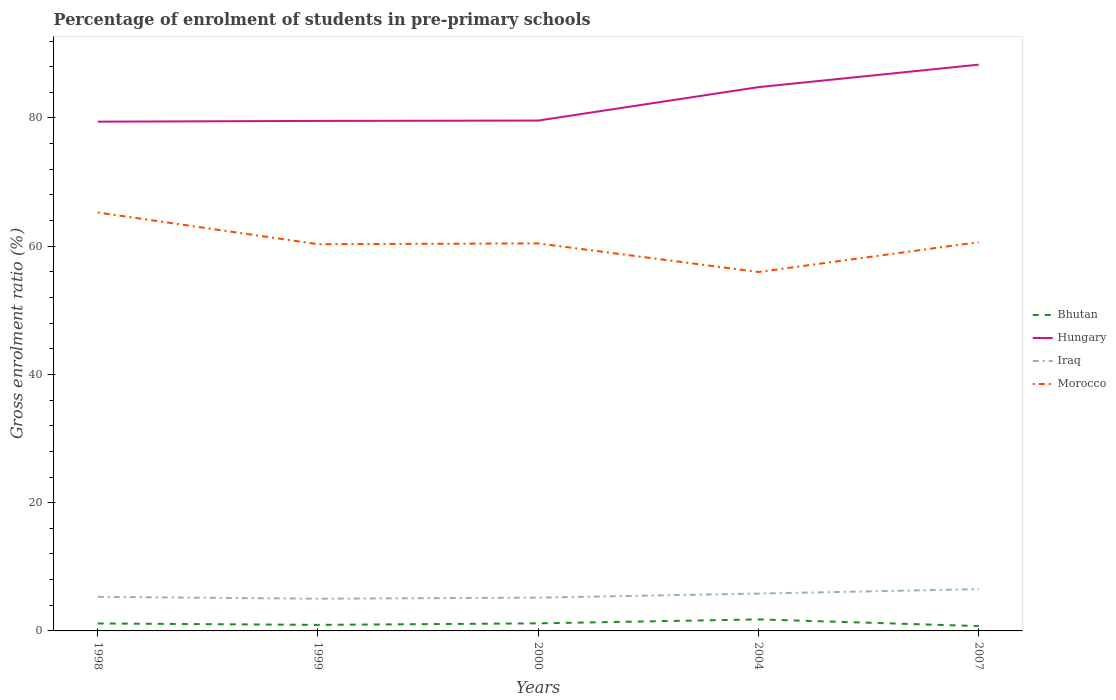Across all years, what is the maximum percentage of students enrolled in pre-primary schools in Morocco?
Give a very brief answer. 55.98. What is the total percentage of students enrolled in pre-primary schools in Iraq in the graph?
Offer a terse response. -0.5. What is the difference between the highest and the second highest percentage of students enrolled in pre-primary schools in Bhutan?
Your answer should be compact. 1.04. What is the difference between the highest and the lowest percentage of students enrolled in pre-primary schools in Morocco?
Give a very brief answer. 2. Is the percentage of students enrolled in pre-primary schools in Bhutan strictly greater than the percentage of students enrolled in pre-primary schools in Morocco over the years?
Give a very brief answer. Yes. Are the values on the major ticks of Y-axis written in scientific E-notation?
Keep it short and to the point. No. Does the graph contain any zero values?
Your answer should be very brief. No. Does the graph contain grids?
Make the answer very short. No. How many legend labels are there?
Make the answer very short. 4. How are the legend labels stacked?
Your answer should be very brief. Vertical. What is the title of the graph?
Provide a succinct answer. Percentage of enrolment of students in pre-primary schools. Does "American Samoa" appear as one of the legend labels in the graph?
Your response must be concise. No. What is the label or title of the X-axis?
Provide a succinct answer. Years. What is the label or title of the Y-axis?
Keep it short and to the point. Gross enrolment ratio (%). What is the Gross enrolment ratio (%) in Bhutan in 1998?
Your answer should be compact. 1.16. What is the Gross enrolment ratio (%) in Hungary in 1998?
Your answer should be very brief. 79.42. What is the Gross enrolment ratio (%) in Iraq in 1998?
Ensure brevity in your answer.  5.32. What is the Gross enrolment ratio (%) of Morocco in 1998?
Provide a short and direct response. 65.26. What is the Gross enrolment ratio (%) of Bhutan in 1999?
Keep it short and to the point. 0.94. What is the Gross enrolment ratio (%) in Hungary in 1999?
Ensure brevity in your answer.  79.54. What is the Gross enrolment ratio (%) in Iraq in 1999?
Ensure brevity in your answer.  5.02. What is the Gross enrolment ratio (%) in Morocco in 1999?
Keep it short and to the point. 60.31. What is the Gross enrolment ratio (%) in Bhutan in 2000?
Your answer should be very brief. 1.18. What is the Gross enrolment ratio (%) of Hungary in 2000?
Offer a very short reply. 79.6. What is the Gross enrolment ratio (%) in Iraq in 2000?
Provide a succinct answer. 5.19. What is the Gross enrolment ratio (%) in Morocco in 2000?
Your response must be concise. 60.43. What is the Gross enrolment ratio (%) in Bhutan in 2004?
Make the answer very short. 1.8. What is the Gross enrolment ratio (%) in Hungary in 2004?
Your response must be concise. 84.81. What is the Gross enrolment ratio (%) of Iraq in 2004?
Ensure brevity in your answer.  5.82. What is the Gross enrolment ratio (%) in Morocco in 2004?
Offer a very short reply. 55.98. What is the Gross enrolment ratio (%) in Bhutan in 2007?
Keep it short and to the point. 0.76. What is the Gross enrolment ratio (%) of Hungary in 2007?
Ensure brevity in your answer.  88.32. What is the Gross enrolment ratio (%) in Iraq in 2007?
Offer a very short reply. 6.52. What is the Gross enrolment ratio (%) of Morocco in 2007?
Offer a terse response. 60.63. Across all years, what is the maximum Gross enrolment ratio (%) in Bhutan?
Provide a succinct answer. 1.8. Across all years, what is the maximum Gross enrolment ratio (%) of Hungary?
Provide a succinct answer. 88.32. Across all years, what is the maximum Gross enrolment ratio (%) of Iraq?
Ensure brevity in your answer.  6.52. Across all years, what is the maximum Gross enrolment ratio (%) of Morocco?
Provide a succinct answer. 65.26. Across all years, what is the minimum Gross enrolment ratio (%) in Bhutan?
Keep it short and to the point. 0.76. Across all years, what is the minimum Gross enrolment ratio (%) of Hungary?
Give a very brief answer. 79.42. Across all years, what is the minimum Gross enrolment ratio (%) of Iraq?
Provide a succinct answer. 5.02. Across all years, what is the minimum Gross enrolment ratio (%) in Morocco?
Your response must be concise. 55.98. What is the total Gross enrolment ratio (%) of Bhutan in the graph?
Give a very brief answer. 5.84. What is the total Gross enrolment ratio (%) in Hungary in the graph?
Offer a very short reply. 411.69. What is the total Gross enrolment ratio (%) of Iraq in the graph?
Keep it short and to the point. 27.87. What is the total Gross enrolment ratio (%) in Morocco in the graph?
Keep it short and to the point. 302.61. What is the difference between the Gross enrolment ratio (%) in Bhutan in 1998 and that in 1999?
Provide a short and direct response. 0.22. What is the difference between the Gross enrolment ratio (%) in Hungary in 1998 and that in 1999?
Give a very brief answer. -0.12. What is the difference between the Gross enrolment ratio (%) of Iraq in 1998 and that in 1999?
Give a very brief answer. 0.29. What is the difference between the Gross enrolment ratio (%) in Morocco in 1998 and that in 1999?
Provide a succinct answer. 4.94. What is the difference between the Gross enrolment ratio (%) of Bhutan in 1998 and that in 2000?
Give a very brief answer. -0.02. What is the difference between the Gross enrolment ratio (%) in Hungary in 1998 and that in 2000?
Give a very brief answer. -0.17. What is the difference between the Gross enrolment ratio (%) of Iraq in 1998 and that in 2000?
Keep it short and to the point. 0.12. What is the difference between the Gross enrolment ratio (%) in Morocco in 1998 and that in 2000?
Your answer should be compact. 4.82. What is the difference between the Gross enrolment ratio (%) of Bhutan in 1998 and that in 2004?
Make the answer very short. -0.63. What is the difference between the Gross enrolment ratio (%) in Hungary in 1998 and that in 2004?
Offer a terse response. -5.39. What is the difference between the Gross enrolment ratio (%) of Iraq in 1998 and that in 2004?
Give a very brief answer. -0.5. What is the difference between the Gross enrolment ratio (%) of Morocco in 1998 and that in 2004?
Offer a very short reply. 9.28. What is the difference between the Gross enrolment ratio (%) of Bhutan in 1998 and that in 2007?
Your answer should be very brief. 0.41. What is the difference between the Gross enrolment ratio (%) of Hungary in 1998 and that in 2007?
Offer a terse response. -8.89. What is the difference between the Gross enrolment ratio (%) of Iraq in 1998 and that in 2007?
Make the answer very short. -1.2. What is the difference between the Gross enrolment ratio (%) in Morocco in 1998 and that in 2007?
Ensure brevity in your answer.  4.63. What is the difference between the Gross enrolment ratio (%) in Bhutan in 1999 and that in 2000?
Make the answer very short. -0.24. What is the difference between the Gross enrolment ratio (%) in Hungary in 1999 and that in 2000?
Your response must be concise. -0.05. What is the difference between the Gross enrolment ratio (%) in Iraq in 1999 and that in 2000?
Provide a short and direct response. -0.17. What is the difference between the Gross enrolment ratio (%) in Morocco in 1999 and that in 2000?
Provide a succinct answer. -0.12. What is the difference between the Gross enrolment ratio (%) in Bhutan in 1999 and that in 2004?
Your answer should be compact. -0.85. What is the difference between the Gross enrolment ratio (%) of Hungary in 1999 and that in 2004?
Your answer should be very brief. -5.27. What is the difference between the Gross enrolment ratio (%) of Iraq in 1999 and that in 2004?
Ensure brevity in your answer.  -0.8. What is the difference between the Gross enrolment ratio (%) of Morocco in 1999 and that in 2004?
Offer a terse response. 4.34. What is the difference between the Gross enrolment ratio (%) of Bhutan in 1999 and that in 2007?
Your answer should be very brief. 0.19. What is the difference between the Gross enrolment ratio (%) in Hungary in 1999 and that in 2007?
Provide a succinct answer. -8.77. What is the difference between the Gross enrolment ratio (%) in Iraq in 1999 and that in 2007?
Your answer should be compact. -1.49. What is the difference between the Gross enrolment ratio (%) in Morocco in 1999 and that in 2007?
Make the answer very short. -0.31. What is the difference between the Gross enrolment ratio (%) of Bhutan in 2000 and that in 2004?
Ensure brevity in your answer.  -0.62. What is the difference between the Gross enrolment ratio (%) of Hungary in 2000 and that in 2004?
Provide a short and direct response. -5.21. What is the difference between the Gross enrolment ratio (%) in Iraq in 2000 and that in 2004?
Your answer should be very brief. -0.63. What is the difference between the Gross enrolment ratio (%) in Morocco in 2000 and that in 2004?
Your answer should be compact. 4.45. What is the difference between the Gross enrolment ratio (%) in Bhutan in 2000 and that in 2007?
Offer a very short reply. 0.43. What is the difference between the Gross enrolment ratio (%) of Hungary in 2000 and that in 2007?
Offer a very short reply. -8.72. What is the difference between the Gross enrolment ratio (%) in Iraq in 2000 and that in 2007?
Offer a terse response. -1.32. What is the difference between the Gross enrolment ratio (%) in Morocco in 2000 and that in 2007?
Your answer should be compact. -0.19. What is the difference between the Gross enrolment ratio (%) in Bhutan in 2004 and that in 2007?
Keep it short and to the point. 1.04. What is the difference between the Gross enrolment ratio (%) of Hungary in 2004 and that in 2007?
Ensure brevity in your answer.  -3.51. What is the difference between the Gross enrolment ratio (%) of Iraq in 2004 and that in 2007?
Ensure brevity in your answer.  -0.69. What is the difference between the Gross enrolment ratio (%) of Morocco in 2004 and that in 2007?
Make the answer very short. -4.65. What is the difference between the Gross enrolment ratio (%) in Bhutan in 1998 and the Gross enrolment ratio (%) in Hungary in 1999?
Offer a very short reply. -78.38. What is the difference between the Gross enrolment ratio (%) in Bhutan in 1998 and the Gross enrolment ratio (%) in Iraq in 1999?
Your answer should be compact. -3.86. What is the difference between the Gross enrolment ratio (%) of Bhutan in 1998 and the Gross enrolment ratio (%) of Morocco in 1999?
Your answer should be compact. -59.15. What is the difference between the Gross enrolment ratio (%) in Hungary in 1998 and the Gross enrolment ratio (%) in Iraq in 1999?
Offer a terse response. 74.4. What is the difference between the Gross enrolment ratio (%) of Hungary in 1998 and the Gross enrolment ratio (%) of Morocco in 1999?
Make the answer very short. 19.11. What is the difference between the Gross enrolment ratio (%) of Iraq in 1998 and the Gross enrolment ratio (%) of Morocco in 1999?
Offer a very short reply. -55. What is the difference between the Gross enrolment ratio (%) in Bhutan in 1998 and the Gross enrolment ratio (%) in Hungary in 2000?
Your answer should be compact. -78.43. What is the difference between the Gross enrolment ratio (%) of Bhutan in 1998 and the Gross enrolment ratio (%) of Iraq in 2000?
Give a very brief answer. -4.03. What is the difference between the Gross enrolment ratio (%) in Bhutan in 1998 and the Gross enrolment ratio (%) in Morocco in 2000?
Your answer should be very brief. -59.27. What is the difference between the Gross enrolment ratio (%) in Hungary in 1998 and the Gross enrolment ratio (%) in Iraq in 2000?
Provide a short and direct response. 74.23. What is the difference between the Gross enrolment ratio (%) in Hungary in 1998 and the Gross enrolment ratio (%) in Morocco in 2000?
Your answer should be compact. 18.99. What is the difference between the Gross enrolment ratio (%) of Iraq in 1998 and the Gross enrolment ratio (%) of Morocco in 2000?
Give a very brief answer. -55.12. What is the difference between the Gross enrolment ratio (%) of Bhutan in 1998 and the Gross enrolment ratio (%) of Hungary in 2004?
Your answer should be compact. -83.65. What is the difference between the Gross enrolment ratio (%) of Bhutan in 1998 and the Gross enrolment ratio (%) of Iraq in 2004?
Offer a very short reply. -4.66. What is the difference between the Gross enrolment ratio (%) of Bhutan in 1998 and the Gross enrolment ratio (%) of Morocco in 2004?
Ensure brevity in your answer.  -54.82. What is the difference between the Gross enrolment ratio (%) of Hungary in 1998 and the Gross enrolment ratio (%) of Iraq in 2004?
Provide a succinct answer. 73.6. What is the difference between the Gross enrolment ratio (%) in Hungary in 1998 and the Gross enrolment ratio (%) in Morocco in 2004?
Your answer should be compact. 23.44. What is the difference between the Gross enrolment ratio (%) of Iraq in 1998 and the Gross enrolment ratio (%) of Morocco in 2004?
Offer a terse response. -50.66. What is the difference between the Gross enrolment ratio (%) of Bhutan in 1998 and the Gross enrolment ratio (%) of Hungary in 2007?
Give a very brief answer. -87.15. What is the difference between the Gross enrolment ratio (%) in Bhutan in 1998 and the Gross enrolment ratio (%) in Iraq in 2007?
Your answer should be very brief. -5.35. What is the difference between the Gross enrolment ratio (%) of Bhutan in 1998 and the Gross enrolment ratio (%) of Morocco in 2007?
Offer a very short reply. -59.46. What is the difference between the Gross enrolment ratio (%) in Hungary in 1998 and the Gross enrolment ratio (%) in Iraq in 2007?
Your answer should be compact. 72.91. What is the difference between the Gross enrolment ratio (%) in Hungary in 1998 and the Gross enrolment ratio (%) in Morocco in 2007?
Provide a short and direct response. 18.8. What is the difference between the Gross enrolment ratio (%) in Iraq in 1998 and the Gross enrolment ratio (%) in Morocco in 2007?
Your answer should be very brief. -55.31. What is the difference between the Gross enrolment ratio (%) of Bhutan in 1999 and the Gross enrolment ratio (%) of Hungary in 2000?
Ensure brevity in your answer.  -78.65. What is the difference between the Gross enrolment ratio (%) in Bhutan in 1999 and the Gross enrolment ratio (%) in Iraq in 2000?
Provide a succinct answer. -4.25. What is the difference between the Gross enrolment ratio (%) in Bhutan in 1999 and the Gross enrolment ratio (%) in Morocco in 2000?
Your answer should be compact. -59.49. What is the difference between the Gross enrolment ratio (%) of Hungary in 1999 and the Gross enrolment ratio (%) of Iraq in 2000?
Give a very brief answer. 74.35. What is the difference between the Gross enrolment ratio (%) of Hungary in 1999 and the Gross enrolment ratio (%) of Morocco in 2000?
Ensure brevity in your answer.  19.11. What is the difference between the Gross enrolment ratio (%) of Iraq in 1999 and the Gross enrolment ratio (%) of Morocco in 2000?
Your answer should be compact. -55.41. What is the difference between the Gross enrolment ratio (%) of Bhutan in 1999 and the Gross enrolment ratio (%) of Hungary in 2004?
Offer a terse response. -83.87. What is the difference between the Gross enrolment ratio (%) in Bhutan in 1999 and the Gross enrolment ratio (%) in Iraq in 2004?
Offer a very short reply. -4.88. What is the difference between the Gross enrolment ratio (%) in Bhutan in 1999 and the Gross enrolment ratio (%) in Morocco in 2004?
Keep it short and to the point. -55.04. What is the difference between the Gross enrolment ratio (%) of Hungary in 1999 and the Gross enrolment ratio (%) of Iraq in 2004?
Provide a short and direct response. 73.72. What is the difference between the Gross enrolment ratio (%) in Hungary in 1999 and the Gross enrolment ratio (%) in Morocco in 2004?
Offer a terse response. 23.56. What is the difference between the Gross enrolment ratio (%) in Iraq in 1999 and the Gross enrolment ratio (%) in Morocco in 2004?
Make the answer very short. -50.96. What is the difference between the Gross enrolment ratio (%) in Bhutan in 1999 and the Gross enrolment ratio (%) in Hungary in 2007?
Provide a short and direct response. -87.37. What is the difference between the Gross enrolment ratio (%) in Bhutan in 1999 and the Gross enrolment ratio (%) in Iraq in 2007?
Ensure brevity in your answer.  -5.57. What is the difference between the Gross enrolment ratio (%) of Bhutan in 1999 and the Gross enrolment ratio (%) of Morocco in 2007?
Ensure brevity in your answer.  -59.68. What is the difference between the Gross enrolment ratio (%) of Hungary in 1999 and the Gross enrolment ratio (%) of Iraq in 2007?
Offer a terse response. 73.03. What is the difference between the Gross enrolment ratio (%) in Hungary in 1999 and the Gross enrolment ratio (%) in Morocco in 2007?
Your answer should be compact. 18.92. What is the difference between the Gross enrolment ratio (%) in Iraq in 1999 and the Gross enrolment ratio (%) in Morocco in 2007?
Your answer should be very brief. -55.6. What is the difference between the Gross enrolment ratio (%) in Bhutan in 2000 and the Gross enrolment ratio (%) in Hungary in 2004?
Ensure brevity in your answer.  -83.63. What is the difference between the Gross enrolment ratio (%) of Bhutan in 2000 and the Gross enrolment ratio (%) of Iraq in 2004?
Your answer should be very brief. -4.64. What is the difference between the Gross enrolment ratio (%) in Bhutan in 2000 and the Gross enrolment ratio (%) in Morocco in 2004?
Your answer should be compact. -54.8. What is the difference between the Gross enrolment ratio (%) of Hungary in 2000 and the Gross enrolment ratio (%) of Iraq in 2004?
Provide a succinct answer. 73.77. What is the difference between the Gross enrolment ratio (%) of Hungary in 2000 and the Gross enrolment ratio (%) of Morocco in 2004?
Give a very brief answer. 23.62. What is the difference between the Gross enrolment ratio (%) of Iraq in 2000 and the Gross enrolment ratio (%) of Morocco in 2004?
Provide a short and direct response. -50.79. What is the difference between the Gross enrolment ratio (%) in Bhutan in 2000 and the Gross enrolment ratio (%) in Hungary in 2007?
Your answer should be very brief. -87.13. What is the difference between the Gross enrolment ratio (%) in Bhutan in 2000 and the Gross enrolment ratio (%) in Iraq in 2007?
Make the answer very short. -5.33. What is the difference between the Gross enrolment ratio (%) in Bhutan in 2000 and the Gross enrolment ratio (%) in Morocco in 2007?
Ensure brevity in your answer.  -59.45. What is the difference between the Gross enrolment ratio (%) in Hungary in 2000 and the Gross enrolment ratio (%) in Iraq in 2007?
Your answer should be compact. 73.08. What is the difference between the Gross enrolment ratio (%) of Hungary in 2000 and the Gross enrolment ratio (%) of Morocco in 2007?
Give a very brief answer. 18.97. What is the difference between the Gross enrolment ratio (%) in Iraq in 2000 and the Gross enrolment ratio (%) in Morocco in 2007?
Offer a terse response. -55.43. What is the difference between the Gross enrolment ratio (%) in Bhutan in 2004 and the Gross enrolment ratio (%) in Hungary in 2007?
Your answer should be very brief. -86.52. What is the difference between the Gross enrolment ratio (%) in Bhutan in 2004 and the Gross enrolment ratio (%) in Iraq in 2007?
Your answer should be very brief. -4.72. What is the difference between the Gross enrolment ratio (%) in Bhutan in 2004 and the Gross enrolment ratio (%) in Morocco in 2007?
Keep it short and to the point. -58.83. What is the difference between the Gross enrolment ratio (%) in Hungary in 2004 and the Gross enrolment ratio (%) in Iraq in 2007?
Your response must be concise. 78.29. What is the difference between the Gross enrolment ratio (%) in Hungary in 2004 and the Gross enrolment ratio (%) in Morocco in 2007?
Make the answer very short. 24.18. What is the difference between the Gross enrolment ratio (%) in Iraq in 2004 and the Gross enrolment ratio (%) in Morocco in 2007?
Make the answer very short. -54.8. What is the average Gross enrolment ratio (%) in Bhutan per year?
Provide a short and direct response. 1.17. What is the average Gross enrolment ratio (%) of Hungary per year?
Provide a succinct answer. 82.34. What is the average Gross enrolment ratio (%) of Iraq per year?
Your answer should be very brief. 5.57. What is the average Gross enrolment ratio (%) of Morocco per year?
Your answer should be very brief. 60.52. In the year 1998, what is the difference between the Gross enrolment ratio (%) of Bhutan and Gross enrolment ratio (%) of Hungary?
Make the answer very short. -78.26. In the year 1998, what is the difference between the Gross enrolment ratio (%) of Bhutan and Gross enrolment ratio (%) of Iraq?
Your response must be concise. -4.15. In the year 1998, what is the difference between the Gross enrolment ratio (%) of Bhutan and Gross enrolment ratio (%) of Morocco?
Offer a very short reply. -64.09. In the year 1998, what is the difference between the Gross enrolment ratio (%) in Hungary and Gross enrolment ratio (%) in Iraq?
Your answer should be very brief. 74.1. In the year 1998, what is the difference between the Gross enrolment ratio (%) in Hungary and Gross enrolment ratio (%) in Morocco?
Provide a short and direct response. 14.17. In the year 1998, what is the difference between the Gross enrolment ratio (%) of Iraq and Gross enrolment ratio (%) of Morocco?
Your answer should be compact. -59.94. In the year 1999, what is the difference between the Gross enrolment ratio (%) in Bhutan and Gross enrolment ratio (%) in Hungary?
Your response must be concise. -78.6. In the year 1999, what is the difference between the Gross enrolment ratio (%) in Bhutan and Gross enrolment ratio (%) in Iraq?
Your response must be concise. -4.08. In the year 1999, what is the difference between the Gross enrolment ratio (%) of Bhutan and Gross enrolment ratio (%) of Morocco?
Your response must be concise. -59.37. In the year 1999, what is the difference between the Gross enrolment ratio (%) of Hungary and Gross enrolment ratio (%) of Iraq?
Give a very brief answer. 74.52. In the year 1999, what is the difference between the Gross enrolment ratio (%) of Hungary and Gross enrolment ratio (%) of Morocco?
Offer a very short reply. 19.23. In the year 1999, what is the difference between the Gross enrolment ratio (%) of Iraq and Gross enrolment ratio (%) of Morocco?
Keep it short and to the point. -55.29. In the year 2000, what is the difference between the Gross enrolment ratio (%) of Bhutan and Gross enrolment ratio (%) of Hungary?
Offer a very short reply. -78.41. In the year 2000, what is the difference between the Gross enrolment ratio (%) in Bhutan and Gross enrolment ratio (%) in Iraq?
Offer a very short reply. -4.01. In the year 2000, what is the difference between the Gross enrolment ratio (%) in Bhutan and Gross enrolment ratio (%) in Morocco?
Your answer should be compact. -59.25. In the year 2000, what is the difference between the Gross enrolment ratio (%) in Hungary and Gross enrolment ratio (%) in Iraq?
Your answer should be very brief. 74.4. In the year 2000, what is the difference between the Gross enrolment ratio (%) in Hungary and Gross enrolment ratio (%) in Morocco?
Keep it short and to the point. 19.16. In the year 2000, what is the difference between the Gross enrolment ratio (%) in Iraq and Gross enrolment ratio (%) in Morocco?
Your answer should be very brief. -55.24. In the year 2004, what is the difference between the Gross enrolment ratio (%) of Bhutan and Gross enrolment ratio (%) of Hungary?
Offer a very short reply. -83.01. In the year 2004, what is the difference between the Gross enrolment ratio (%) in Bhutan and Gross enrolment ratio (%) in Iraq?
Make the answer very short. -4.03. In the year 2004, what is the difference between the Gross enrolment ratio (%) of Bhutan and Gross enrolment ratio (%) of Morocco?
Provide a short and direct response. -54.18. In the year 2004, what is the difference between the Gross enrolment ratio (%) in Hungary and Gross enrolment ratio (%) in Iraq?
Ensure brevity in your answer.  78.99. In the year 2004, what is the difference between the Gross enrolment ratio (%) in Hungary and Gross enrolment ratio (%) in Morocco?
Offer a terse response. 28.83. In the year 2004, what is the difference between the Gross enrolment ratio (%) in Iraq and Gross enrolment ratio (%) in Morocco?
Your answer should be compact. -50.16. In the year 2007, what is the difference between the Gross enrolment ratio (%) of Bhutan and Gross enrolment ratio (%) of Hungary?
Provide a succinct answer. -87.56. In the year 2007, what is the difference between the Gross enrolment ratio (%) in Bhutan and Gross enrolment ratio (%) in Iraq?
Ensure brevity in your answer.  -5.76. In the year 2007, what is the difference between the Gross enrolment ratio (%) in Bhutan and Gross enrolment ratio (%) in Morocco?
Make the answer very short. -59.87. In the year 2007, what is the difference between the Gross enrolment ratio (%) in Hungary and Gross enrolment ratio (%) in Iraq?
Provide a short and direct response. 81.8. In the year 2007, what is the difference between the Gross enrolment ratio (%) in Hungary and Gross enrolment ratio (%) in Morocco?
Your answer should be compact. 27.69. In the year 2007, what is the difference between the Gross enrolment ratio (%) in Iraq and Gross enrolment ratio (%) in Morocco?
Give a very brief answer. -54.11. What is the ratio of the Gross enrolment ratio (%) in Bhutan in 1998 to that in 1999?
Your answer should be compact. 1.23. What is the ratio of the Gross enrolment ratio (%) of Iraq in 1998 to that in 1999?
Give a very brief answer. 1.06. What is the ratio of the Gross enrolment ratio (%) of Morocco in 1998 to that in 1999?
Your response must be concise. 1.08. What is the ratio of the Gross enrolment ratio (%) of Bhutan in 1998 to that in 2000?
Ensure brevity in your answer.  0.99. What is the ratio of the Gross enrolment ratio (%) in Hungary in 1998 to that in 2000?
Provide a short and direct response. 1. What is the ratio of the Gross enrolment ratio (%) in Morocco in 1998 to that in 2000?
Your answer should be very brief. 1.08. What is the ratio of the Gross enrolment ratio (%) of Bhutan in 1998 to that in 2004?
Keep it short and to the point. 0.65. What is the ratio of the Gross enrolment ratio (%) in Hungary in 1998 to that in 2004?
Ensure brevity in your answer.  0.94. What is the ratio of the Gross enrolment ratio (%) in Iraq in 1998 to that in 2004?
Your response must be concise. 0.91. What is the ratio of the Gross enrolment ratio (%) in Morocco in 1998 to that in 2004?
Your answer should be very brief. 1.17. What is the ratio of the Gross enrolment ratio (%) of Bhutan in 1998 to that in 2007?
Provide a short and direct response. 1.54. What is the ratio of the Gross enrolment ratio (%) of Hungary in 1998 to that in 2007?
Provide a short and direct response. 0.9. What is the ratio of the Gross enrolment ratio (%) in Iraq in 1998 to that in 2007?
Ensure brevity in your answer.  0.82. What is the ratio of the Gross enrolment ratio (%) in Morocco in 1998 to that in 2007?
Make the answer very short. 1.08. What is the ratio of the Gross enrolment ratio (%) in Bhutan in 1999 to that in 2000?
Your answer should be very brief. 0.8. What is the ratio of the Gross enrolment ratio (%) of Hungary in 1999 to that in 2000?
Your answer should be compact. 1. What is the ratio of the Gross enrolment ratio (%) of Iraq in 1999 to that in 2000?
Offer a terse response. 0.97. What is the ratio of the Gross enrolment ratio (%) in Bhutan in 1999 to that in 2004?
Your answer should be compact. 0.52. What is the ratio of the Gross enrolment ratio (%) in Hungary in 1999 to that in 2004?
Your response must be concise. 0.94. What is the ratio of the Gross enrolment ratio (%) in Iraq in 1999 to that in 2004?
Offer a very short reply. 0.86. What is the ratio of the Gross enrolment ratio (%) in Morocco in 1999 to that in 2004?
Provide a succinct answer. 1.08. What is the ratio of the Gross enrolment ratio (%) in Bhutan in 1999 to that in 2007?
Ensure brevity in your answer.  1.25. What is the ratio of the Gross enrolment ratio (%) of Hungary in 1999 to that in 2007?
Your answer should be very brief. 0.9. What is the ratio of the Gross enrolment ratio (%) of Iraq in 1999 to that in 2007?
Your answer should be very brief. 0.77. What is the ratio of the Gross enrolment ratio (%) in Morocco in 1999 to that in 2007?
Offer a very short reply. 0.99. What is the ratio of the Gross enrolment ratio (%) of Bhutan in 2000 to that in 2004?
Give a very brief answer. 0.66. What is the ratio of the Gross enrolment ratio (%) of Hungary in 2000 to that in 2004?
Provide a short and direct response. 0.94. What is the ratio of the Gross enrolment ratio (%) of Iraq in 2000 to that in 2004?
Provide a succinct answer. 0.89. What is the ratio of the Gross enrolment ratio (%) of Morocco in 2000 to that in 2004?
Offer a terse response. 1.08. What is the ratio of the Gross enrolment ratio (%) in Bhutan in 2000 to that in 2007?
Make the answer very short. 1.56. What is the ratio of the Gross enrolment ratio (%) in Hungary in 2000 to that in 2007?
Ensure brevity in your answer.  0.9. What is the ratio of the Gross enrolment ratio (%) of Iraq in 2000 to that in 2007?
Your answer should be very brief. 0.8. What is the ratio of the Gross enrolment ratio (%) in Morocco in 2000 to that in 2007?
Give a very brief answer. 1. What is the ratio of the Gross enrolment ratio (%) in Bhutan in 2004 to that in 2007?
Offer a terse response. 2.38. What is the ratio of the Gross enrolment ratio (%) of Hungary in 2004 to that in 2007?
Offer a very short reply. 0.96. What is the ratio of the Gross enrolment ratio (%) in Iraq in 2004 to that in 2007?
Provide a succinct answer. 0.89. What is the ratio of the Gross enrolment ratio (%) in Morocco in 2004 to that in 2007?
Make the answer very short. 0.92. What is the difference between the highest and the second highest Gross enrolment ratio (%) in Bhutan?
Keep it short and to the point. 0.62. What is the difference between the highest and the second highest Gross enrolment ratio (%) in Hungary?
Your answer should be very brief. 3.51. What is the difference between the highest and the second highest Gross enrolment ratio (%) in Iraq?
Your answer should be compact. 0.69. What is the difference between the highest and the second highest Gross enrolment ratio (%) of Morocco?
Provide a short and direct response. 4.63. What is the difference between the highest and the lowest Gross enrolment ratio (%) in Bhutan?
Provide a succinct answer. 1.04. What is the difference between the highest and the lowest Gross enrolment ratio (%) in Hungary?
Give a very brief answer. 8.89. What is the difference between the highest and the lowest Gross enrolment ratio (%) of Iraq?
Your response must be concise. 1.49. What is the difference between the highest and the lowest Gross enrolment ratio (%) in Morocco?
Give a very brief answer. 9.28. 